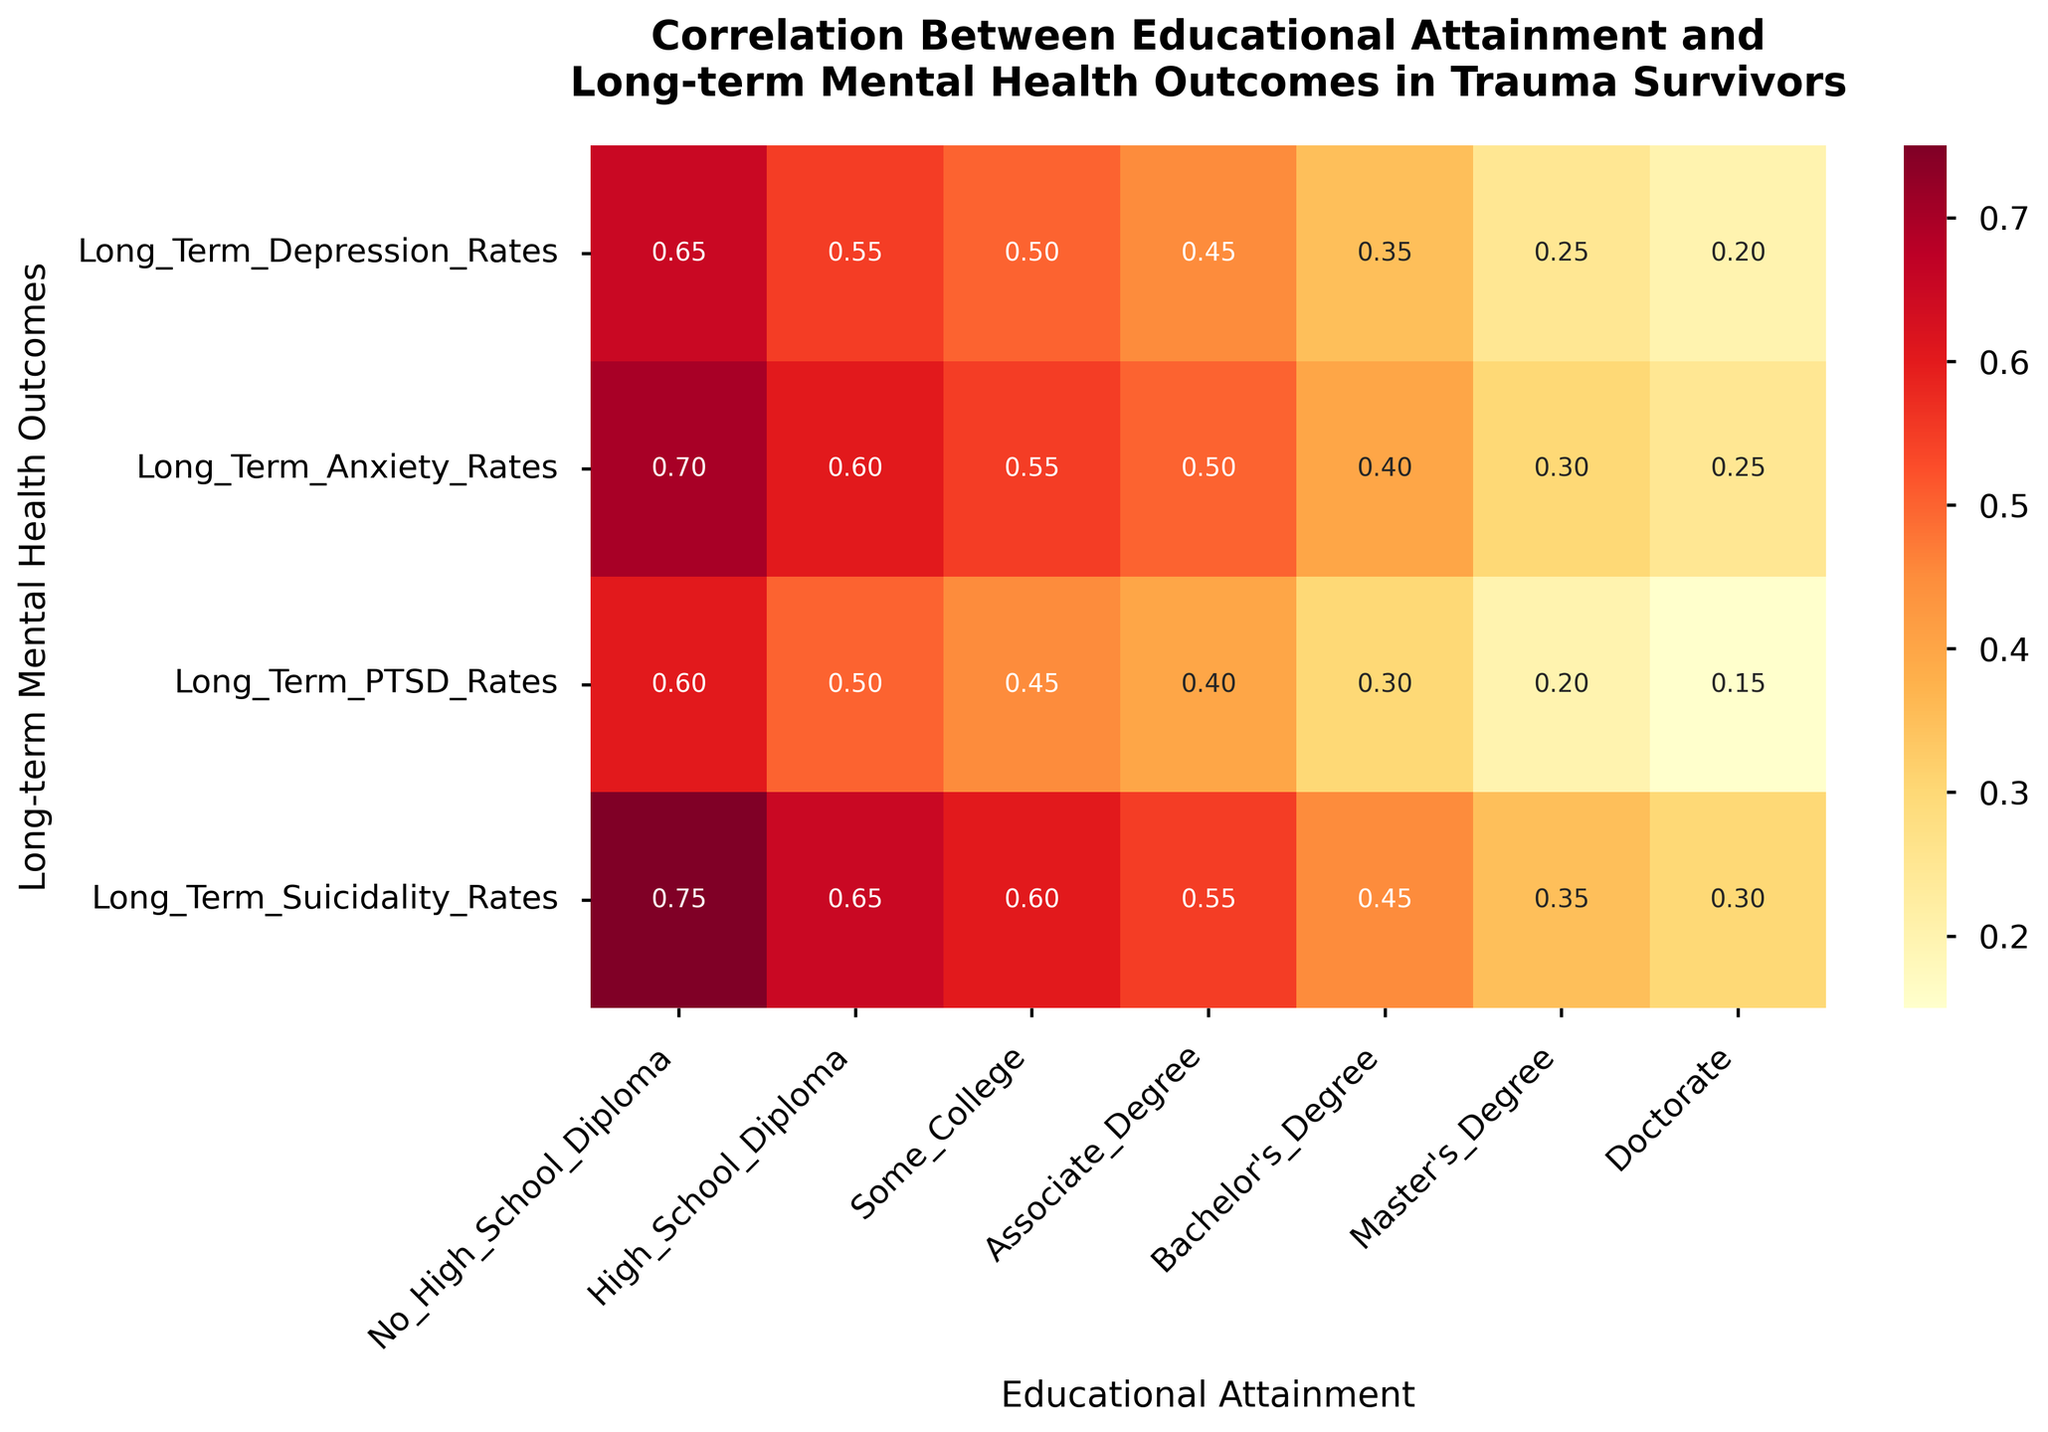What's the title of the heatmap? The title is often positioned at the top of the figure. Here, it states "Correlation Between Educational Attainment and Long-term Mental Health Outcomes in Trauma Survivors".
Answer: Correlation Between Educational Attainment and Long-term Mental Health Outcomes in Trauma Survivors Which mental health outcome has the highest depression rate for individuals with no high school diploma? Locate the column for "No High School Diploma", then find the value under "Long-term Depression Rates". The value is 0.65.
Answer: Long-term Depression Rates What’s the depression rate for individuals with a Master's Degree? Find the column labeled "Master's Degree" and look at the value under "Long-term Depression Rates". The value is 0.25.
Answer: 0.25 How do anxiety rates compare between individuals with a Bachelor’s Degree and those with a Doctorate? Locate the anxiety rates for both “Bachelor’s Degree” (0.40) and “Doctorate” (0.25). Comparing these, 0.40 is higher than 0.25.
Answer: Anxiety rates are higher for Bachelor’s Degree (0.40) compared to Doctorate (0.25) What is the range of PTSD rates for individuals with Some College education? Locate "Some College" and find the PTSD rate (0.45). The range of a single value is just that value.
Answer: 0.45 Which level of educational attainment is associated with the lowest suicidality rate? In the row for "Long-term Suicidality Rates", find the smallest value. The smallest value is 0.30 for individuals with a Doctorate.
Answer: Doctorate How much lower is the depression rate for individuals with an Associate Degree compared to those with a High School Diploma? Find the depression rates for "Associate Degree" (0.45) and "High School Diploma" (0.55). Subtract the smaller value from the larger value: 0.55 - 0.45 = 0.10.
Answer: 0.10 Which educational level shows the greatest improvement in anxiety rates compared to not having a High School Diploma? Compute the differences in anxiety rates between "No High School Diploma" (0.70) and each educational level: High School Diploma (0.60), Some College (0.55), Associate Degree (0.50), Bachelor’s Degree (0.40), Master’s Degree (0.30), Doctorate (0.25). The greatest improvement is for Doctorate: 0.70 - 0.25 = 0.45.
Answer: Doctorate Is there a clear trend in PTSD rates with increased educational attainment? Look at the PTSD rates row and compare values across increasing educational levels: 0.60, 0.50, 0.45, 0.40, 0.30, 0.20, 0.15. There is a downward trend, indicating PTSD rates decrease with higher education levels.
Answer: Yes What mental health outcome is most affected by obtaining a Bachelor’s Degree compared to no High School Diploma? Compare the rate differences for depression, anxiety, PTSD, and suicidality between "No High School Diploma" and "Bachelor’s Degree". The changes are: depression (-0.65 to -0.35 = -0.30), anxiety (-0.70 to -0.40 = -0.30), PTSD (-0.60 to -0.30 = -0.30), suicidality (-0.75 to -0.45 = -0.30). All outcomes reflect a consistent 0.30 decrease.
Answer: All outcomes equally 